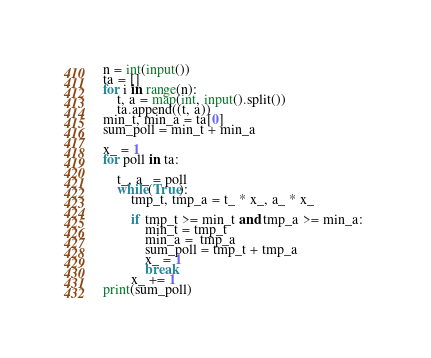<code> <loc_0><loc_0><loc_500><loc_500><_Python_>n = int(input())
ta = []
for i in range(n):
    t, a = map(int, input().split())
    ta.append((t, a))
min_t, min_a = ta[0]
sum_poll = min_t + min_a

x_ = 1
for poll in ta:

    t_, a_ = poll
    while(True):
        tmp_t, tmp_a = t_ * x_, a_ * x_

        if tmp_t >= min_t and tmp_a >= min_a: 
            min_t = tmp_t
            min_a =  tmp_a
            sum_poll = tmp_t + tmp_a
            x_ = 1
            break
        x_ += 1
print(sum_poll)</code> 